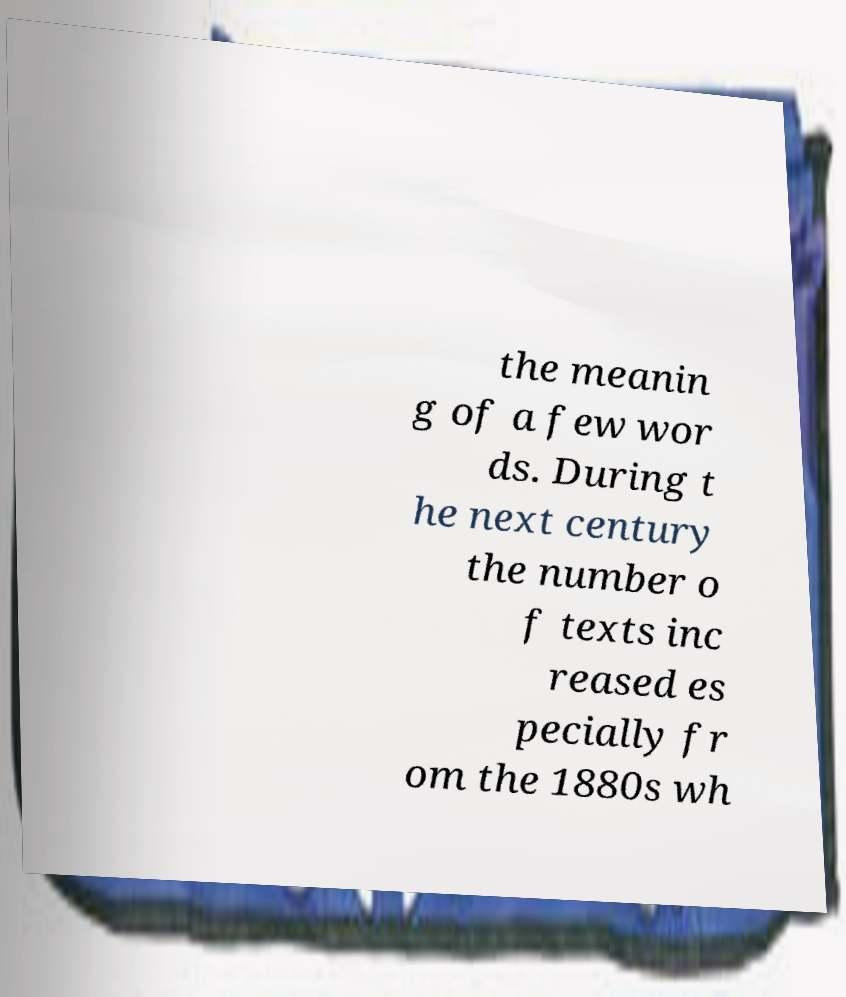There's text embedded in this image that I need extracted. Can you transcribe it verbatim? the meanin g of a few wor ds. During t he next century the number o f texts inc reased es pecially fr om the 1880s wh 